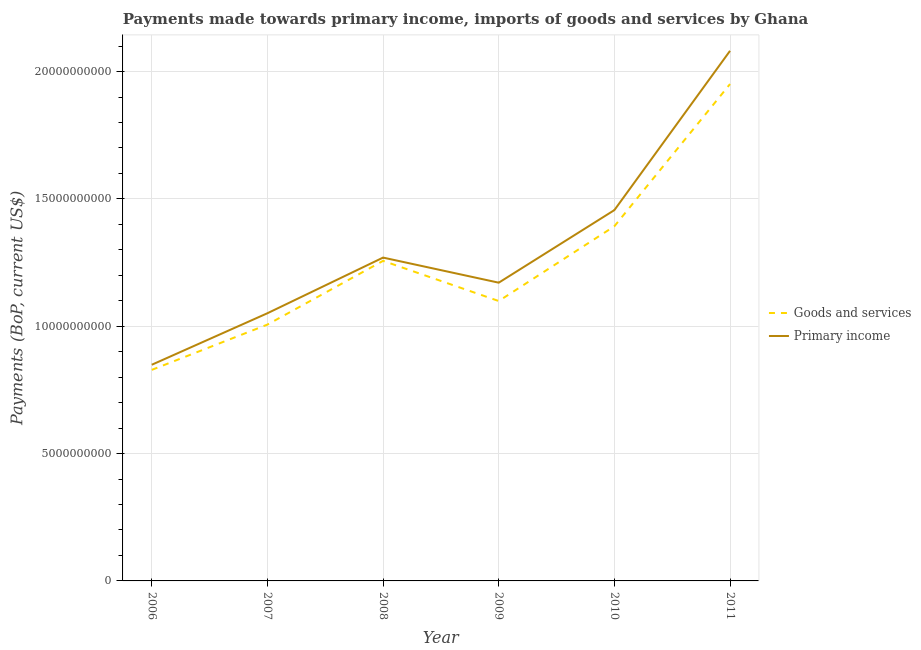Does the line corresponding to payments made towards primary income intersect with the line corresponding to payments made towards goods and services?
Provide a short and direct response. No. Is the number of lines equal to the number of legend labels?
Offer a very short reply. Yes. What is the payments made towards goods and services in 2009?
Provide a succinct answer. 1.10e+1. Across all years, what is the maximum payments made towards primary income?
Make the answer very short. 2.08e+1. Across all years, what is the minimum payments made towards primary income?
Provide a short and direct response. 8.49e+09. In which year was the payments made towards goods and services maximum?
Your response must be concise. 2011. In which year was the payments made towards goods and services minimum?
Offer a terse response. 2006. What is the total payments made towards goods and services in the graph?
Give a very brief answer. 7.53e+1. What is the difference between the payments made towards goods and services in 2009 and that in 2011?
Your answer should be compact. -8.52e+09. What is the difference between the payments made towards primary income in 2011 and the payments made towards goods and services in 2006?
Your answer should be very brief. 1.25e+1. What is the average payments made towards goods and services per year?
Make the answer very short. 1.26e+1. In the year 2010, what is the difference between the payments made towards goods and services and payments made towards primary income?
Offer a very short reply. -6.35e+08. In how many years, is the payments made towards primary income greater than 20000000000 US$?
Make the answer very short. 1. What is the ratio of the payments made towards goods and services in 2006 to that in 2009?
Give a very brief answer. 0.75. Is the payments made towards goods and services in 2008 less than that in 2010?
Keep it short and to the point. Yes. What is the difference between the highest and the second highest payments made towards goods and services?
Your response must be concise. 5.58e+09. What is the difference between the highest and the lowest payments made towards goods and services?
Ensure brevity in your answer.  1.12e+1. Does the payments made towards goods and services monotonically increase over the years?
Provide a succinct answer. No. Is the payments made towards primary income strictly less than the payments made towards goods and services over the years?
Your response must be concise. No. How many years are there in the graph?
Give a very brief answer. 6. Does the graph contain any zero values?
Your answer should be compact. No. Where does the legend appear in the graph?
Make the answer very short. Center right. How many legend labels are there?
Your answer should be very brief. 2. What is the title of the graph?
Ensure brevity in your answer.  Payments made towards primary income, imports of goods and services by Ghana. What is the label or title of the X-axis?
Your answer should be very brief. Year. What is the label or title of the Y-axis?
Make the answer very short. Payments (BoP, current US$). What is the Payments (BoP, current US$) in Goods and services in 2006?
Your answer should be compact. 8.29e+09. What is the Payments (BoP, current US$) in Primary income in 2006?
Ensure brevity in your answer.  8.49e+09. What is the Payments (BoP, current US$) of Goods and services in 2007?
Offer a very short reply. 1.01e+1. What is the Payments (BoP, current US$) of Primary income in 2007?
Your answer should be compact. 1.05e+1. What is the Payments (BoP, current US$) of Goods and services in 2008?
Offer a terse response. 1.26e+1. What is the Payments (BoP, current US$) of Primary income in 2008?
Provide a short and direct response. 1.27e+1. What is the Payments (BoP, current US$) of Goods and services in 2009?
Offer a very short reply. 1.10e+1. What is the Payments (BoP, current US$) in Primary income in 2009?
Provide a short and direct response. 1.17e+1. What is the Payments (BoP, current US$) of Goods and services in 2010?
Offer a very short reply. 1.39e+1. What is the Payments (BoP, current US$) in Primary income in 2010?
Provide a succinct answer. 1.46e+1. What is the Payments (BoP, current US$) of Goods and services in 2011?
Offer a terse response. 1.95e+1. What is the Payments (BoP, current US$) of Primary income in 2011?
Your response must be concise. 2.08e+1. Across all years, what is the maximum Payments (BoP, current US$) of Goods and services?
Offer a terse response. 1.95e+1. Across all years, what is the maximum Payments (BoP, current US$) of Primary income?
Offer a very short reply. 2.08e+1. Across all years, what is the minimum Payments (BoP, current US$) of Goods and services?
Give a very brief answer. 8.29e+09. Across all years, what is the minimum Payments (BoP, current US$) in Primary income?
Give a very brief answer. 8.49e+09. What is the total Payments (BoP, current US$) in Goods and services in the graph?
Your response must be concise. 7.53e+1. What is the total Payments (BoP, current US$) of Primary income in the graph?
Keep it short and to the point. 7.88e+1. What is the difference between the Payments (BoP, current US$) in Goods and services in 2006 and that in 2007?
Your answer should be compact. -1.78e+09. What is the difference between the Payments (BoP, current US$) of Primary income in 2006 and that in 2007?
Provide a succinct answer. -2.02e+09. What is the difference between the Payments (BoP, current US$) in Goods and services in 2006 and that in 2008?
Your response must be concise. -4.28e+09. What is the difference between the Payments (BoP, current US$) of Primary income in 2006 and that in 2008?
Provide a short and direct response. -4.21e+09. What is the difference between the Payments (BoP, current US$) in Goods and services in 2006 and that in 2009?
Make the answer very short. -2.70e+09. What is the difference between the Payments (BoP, current US$) in Primary income in 2006 and that in 2009?
Make the answer very short. -3.22e+09. What is the difference between the Payments (BoP, current US$) in Goods and services in 2006 and that in 2010?
Make the answer very short. -5.64e+09. What is the difference between the Payments (BoP, current US$) in Primary income in 2006 and that in 2010?
Your answer should be compact. -6.07e+09. What is the difference between the Payments (BoP, current US$) in Goods and services in 2006 and that in 2011?
Offer a terse response. -1.12e+1. What is the difference between the Payments (BoP, current US$) in Primary income in 2006 and that in 2011?
Your answer should be very brief. -1.23e+1. What is the difference between the Payments (BoP, current US$) in Goods and services in 2007 and that in 2008?
Your answer should be very brief. -2.50e+09. What is the difference between the Payments (BoP, current US$) in Primary income in 2007 and that in 2008?
Make the answer very short. -2.19e+09. What is the difference between the Payments (BoP, current US$) of Goods and services in 2007 and that in 2009?
Offer a terse response. -9.25e+08. What is the difference between the Payments (BoP, current US$) in Primary income in 2007 and that in 2009?
Your answer should be very brief. -1.20e+09. What is the difference between the Payments (BoP, current US$) in Goods and services in 2007 and that in 2010?
Give a very brief answer. -3.86e+09. What is the difference between the Payments (BoP, current US$) of Primary income in 2007 and that in 2010?
Offer a very short reply. -4.05e+09. What is the difference between the Payments (BoP, current US$) in Goods and services in 2007 and that in 2011?
Make the answer very short. -9.44e+09. What is the difference between the Payments (BoP, current US$) of Primary income in 2007 and that in 2011?
Make the answer very short. -1.03e+1. What is the difference between the Payments (BoP, current US$) in Goods and services in 2008 and that in 2009?
Your answer should be compact. 1.58e+09. What is the difference between the Payments (BoP, current US$) of Primary income in 2008 and that in 2009?
Offer a very short reply. 9.85e+08. What is the difference between the Payments (BoP, current US$) in Goods and services in 2008 and that in 2010?
Offer a terse response. -1.36e+09. What is the difference between the Payments (BoP, current US$) in Primary income in 2008 and that in 2010?
Your response must be concise. -1.86e+09. What is the difference between the Payments (BoP, current US$) of Goods and services in 2008 and that in 2011?
Offer a very short reply. -6.94e+09. What is the difference between the Payments (BoP, current US$) of Primary income in 2008 and that in 2011?
Ensure brevity in your answer.  -8.12e+09. What is the difference between the Payments (BoP, current US$) of Goods and services in 2009 and that in 2010?
Keep it short and to the point. -2.94e+09. What is the difference between the Payments (BoP, current US$) of Primary income in 2009 and that in 2010?
Ensure brevity in your answer.  -2.85e+09. What is the difference between the Payments (BoP, current US$) of Goods and services in 2009 and that in 2011?
Give a very brief answer. -8.52e+09. What is the difference between the Payments (BoP, current US$) in Primary income in 2009 and that in 2011?
Offer a terse response. -9.10e+09. What is the difference between the Payments (BoP, current US$) of Goods and services in 2010 and that in 2011?
Provide a succinct answer. -5.58e+09. What is the difference between the Payments (BoP, current US$) in Primary income in 2010 and that in 2011?
Make the answer very short. -6.25e+09. What is the difference between the Payments (BoP, current US$) in Goods and services in 2006 and the Payments (BoP, current US$) in Primary income in 2007?
Make the answer very short. -2.22e+09. What is the difference between the Payments (BoP, current US$) of Goods and services in 2006 and the Payments (BoP, current US$) of Primary income in 2008?
Your response must be concise. -4.41e+09. What is the difference between the Payments (BoP, current US$) of Goods and services in 2006 and the Payments (BoP, current US$) of Primary income in 2009?
Your response must be concise. -3.42e+09. What is the difference between the Payments (BoP, current US$) of Goods and services in 2006 and the Payments (BoP, current US$) of Primary income in 2010?
Offer a very short reply. -6.27e+09. What is the difference between the Payments (BoP, current US$) in Goods and services in 2006 and the Payments (BoP, current US$) in Primary income in 2011?
Ensure brevity in your answer.  -1.25e+1. What is the difference between the Payments (BoP, current US$) of Goods and services in 2007 and the Payments (BoP, current US$) of Primary income in 2008?
Offer a terse response. -2.63e+09. What is the difference between the Payments (BoP, current US$) of Goods and services in 2007 and the Payments (BoP, current US$) of Primary income in 2009?
Your answer should be compact. -1.65e+09. What is the difference between the Payments (BoP, current US$) in Goods and services in 2007 and the Payments (BoP, current US$) in Primary income in 2010?
Your response must be concise. -4.50e+09. What is the difference between the Payments (BoP, current US$) in Goods and services in 2007 and the Payments (BoP, current US$) in Primary income in 2011?
Make the answer very short. -1.07e+1. What is the difference between the Payments (BoP, current US$) of Goods and services in 2008 and the Payments (BoP, current US$) of Primary income in 2009?
Keep it short and to the point. 8.57e+08. What is the difference between the Payments (BoP, current US$) of Goods and services in 2008 and the Payments (BoP, current US$) of Primary income in 2010?
Offer a terse response. -1.99e+09. What is the difference between the Payments (BoP, current US$) of Goods and services in 2008 and the Payments (BoP, current US$) of Primary income in 2011?
Your answer should be very brief. -8.25e+09. What is the difference between the Payments (BoP, current US$) in Goods and services in 2009 and the Payments (BoP, current US$) in Primary income in 2010?
Ensure brevity in your answer.  -3.57e+09. What is the difference between the Payments (BoP, current US$) of Goods and services in 2009 and the Payments (BoP, current US$) of Primary income in 2011?
Provide a succinct answer. -9.82e+09. What is the difference between the Payments (BoP, current US$) in Goods and services in 2010 and the Payments (BoP, current US$) in Primary income in 2011?
Your answer should be compact. -6.89e+09. What is the average Payments (BoP, current US$) in Goods and services per year?
Provide a succinct answer. 1.26e+1. What is the average Payments (BoP, current US$) in Primary income per year?
Offer a terse response. 1.31e+1. In the year 2006, what is the difference between the Payments (BoP, current US$) of Goods and services and Payments (BoP, current US$) of Primary income?
Your answer should be very brief. -2.01e+08. In the year 2007, what is the difference between the Payments (BoP, current US$) in Goods and services and Payments (BoP, current US$) in Primary income?
Offer a very short reply. -4.45e+08. In the year 2008, what is the difference between the Payments (BoP, current US$) of Goods and services and Payments (BoP, current US$) of Primary income?
Provide a short and direct response. -1.29e+08. In the year 2009, what is the difference between the Payments (BoP, current US$) of Goods and services and Payments (BoP, current US$) of Primary income?
Provide a short and direct response. -7.20e+08. In the year 2010, what is the difference between the Payments (BoP, current US$) in Goods and services and Payments (BoP, current US$) in Primary income?
Provide a succinct answer. -6.35e+08. In the year 2011, what is the difference between the Payments (BoP, current US$) in Goods and services and Payments (BoP, current US$) in Primary income?
Your answer should be very brief. -1.30e+09. What is the ratio of the Payments (BoP, current US$) of Goods and services in 2006 to that in 2007?
Your answer should be very brief. 0.82. What is the ratio of the Payments (BoP, current US$) of Primary income in 2006 to that in 2007?
Ensure brevity in your answer.  0.81. What is the ratio of the Payments (BoP, current US$) in Goods and services in 2006 to that in 2008?
Provide a short and direct response. 0.66. What is the ratio of the Payments (BoP, current US$) in Primary income in 2006 to that in 2008?
Ensure brevity in your answer.  0.67. What is the ratio of the Payments (BoP, current US$) in Goods and services in 2006 to that in 2009?
Give a very brief answer. 0.75. What is the ratio of the Payments (BoP, current US$) of Primary income in 2006 to that in 2009?
Make the answer very short. 0.72. What is the ratio of the Payments (BoP, current US$) in Goods and services in 2006 to that in 2010?
Give a very brief answer. 0.6. What is the ratio of the Payments (BoP, current US$) of Primary income in 2006 to that in 2010?
Your answer should be compact. 0.58. What is the ratio of the Payments (BoP, current US$) of Goods and services in 2006 to that in 2011?
Provide a short and direct response. 0.42. What is the ratio of the Payments (BoP, current US$) in Primary income in 2006 to that in 2011?
Your answer should be very brief. 0.41. What is the ratio of the Payments (BoP, current US$) of Goods and services in 2007 to that in 2008?
Offer a very short reply. 0.8. What is the ratio of the Payments (BoP, current US$) of Primary income in 2007 to that in 2008?
Offer a very short reply. 0.83. What is the ratio of the Payments (BoP, current US$) in Goods and services in 2007 to that in 2009?
Your answer should be very brief. 0.92. What is the ratio of the Payments (BoP, current US$) in Primary income in 2007 to that in 2009?
Offer a terse response. 0.9. What is the ratio of the Payments (BoP, current US$) in Goods and services in 2007 to that in 2010?
Your answer should be compact. 0.72. What is the ratio of the Payments (BoP, current US$) in Primary income in 2007 to that in 2010?
Your answer should be compact. 0.72. What is the ratio of the Payments (BoP, current US$) of Goods and services in 2007 to that in 2011?
Give a very brief answer. 0.52. What is the ratio of the Payments (BoP, current US$) of Primary income in 2007 to that in 2011?
Keep it short and to the point. 0.51. What is the ratio of the Payments (BoP, current US$) of Goods and services in 2008 to that in 2009?
Offer a very short reply. 1.14. What is the ratio of the Payments (BoP, current US$) in Primary income in 2008 to that in 2009?
Provide a succinct answer. 1.08. What is the ratio of the Payments (BoP, current US$) of Goods and services in 2008 to that in 2010?
Ensure brevity in your answer.  0.9. What is the ratio of the Payments (BoP, current US$) in Primary income in 2008 to that in 2010?
Provide a short and direct response. 0.87. What is the ratio of the Payments (BoP, current US$) of Goods and services in 2008 to that in 2011?
Offer a terse response. 0.64. What is the ratio of the Payments (BoP, current US$) of Primary income in 2008 to that in 2011?
Provide a short and direct response. 0.61. What is the ratio of the Payments (BoP, current US$) in Goods and services in 2009 to that in 2010?
Offer a terse response. 0.79. What is the ratio of the Payments (BoP, current US$) of Primary income in 2009 to that in 2010?
Provide a short and direct response. 0.8. What is the ratio of the Payments (BoP, current US$) in Goods and services in 2009 to that in 2011?
Ensure brevity in your answer.  0.56. What is the ratio of the Payments (BoP, current US$) of Primary income in 2009 to that in 2011?
Make the answer very short. 0.56. What is the ratio of the Payments (BoP, current US$) in Goods and services in 2010 to that in 2011?
Offer a very short reply. 0.71. What is the ratio of the Payments (BoP, current US$) of Primary income in 2010 to that in 2011?
Your response must be concise. 0.7. What is the difference between the highest and the second highest Payments (BoP, current US$) of Goods and services?
Ensure brevity in your answer.  5.58e+09. What is the difference between the highest and the second highest Payments (BoP, current US$) in Primary income?
Your answer should be very brief. 6.25e+09. What is the difference between the highest and the lowest Payments (BoP, current US$) of Goods and services?
Offer a terse response. 1.12e+1. What is the difference between the highest and the lowest Payments (BoP, current US$) in Primary income?
Offer a terse response. 1.23e+1. 